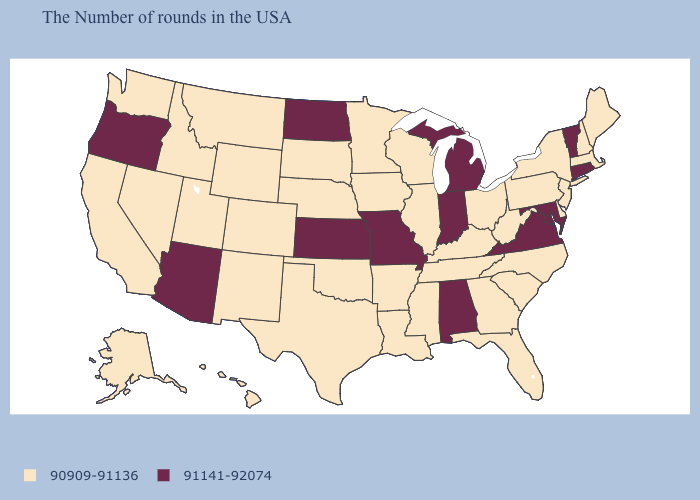Which states have the highest value in the USA?
Give a very brief answer. Rhode Island, Vermont, Connecticut, Maryland, Virginia, Michigan, Indiana, Alabama, Missouri, Kansas, North Dakota, Arizona, Oregon. Name the states that have a value in the range 90909-91136?
Concise answer only. Maine, Massachusetts, New Hampshire, New York, New Jersey, Delaware, Pennsylvania, North Carolina, South Carolina, West Virginia, Ohio, Florida, Georgia, Kentucky, Tennessee, Wisconsin, Illinois, Mississippi, Louisiana, Arkansas, Minnesota, Iowa, Nebraska, Oklahoma, Texas, South Dakota, Wyoming, Colorado, New Mexico, Utah, Montana, Idaho, Nevada, California, Washington, Alaska, Hawaii. Name the states that have a value in the range 90909-91136?
Write a very short answer. Maine, Massachusetts, New Hampshire, New York, New Jersey, Delaware, Pennsylvania, North Carolina, South Carolina, West Virginia, Ohio, Florida, Georgia, Kentucky, Tennessee, Wisconsin, Illinois, Mississippi, Louisiana, Arkansas, Minnesota, Iowa, Nebraska, Oklahoma, Texas, South Dakota, Wyoming, Colorado, New Mexico, Utah, Montana, Idaho, Nevada, California, Washington, Alaska, Hawaii. How many symbols are there in the legend?
Give a very brief answer. 2. Which states have the lowest value in the USA?
Keep it brief. Maine, Massachusetts, New Hampshire, New York, New Jersey, Delaware, Pennsylvania, North Carolina, South Carolina, West Virginia, Ohio, Florida, Georgia, Kentucky, Tennessee, Wisconsin, Illinois, Mississippi, Louisiana, Arkansas, Minnesota, Iowa, Nebraska, Oklahoma, Texas, South Dakota, Wyoming, Colorado, New Mexico, Utah, Montana, Idaho, Nevada, California, Washington, Alaska, Hawaii. What is the value of Texas?
Concise answer only. 90909-91136. What is the value of Alabama?
Answer briefly. 91141-92074. What is the highest value in the USA?
Write a very short answer. 91141-92074. What is the lowest value in the USA?
Answer briefly. 90909-91136. What is the value of North Dakota?
Concise answer only. 91141-92074. What is the highest value in states that border North Dakota?
Give a very brief answer. 90909-91136. Among the states that border South Dakota , which have the lowest value?
Keep it brief. Minnesota, Iowa, Nebraska, Wyoming, Montana. Name the states that have a value in the range 91141-92074?
Concise answer only. Rhode Island, Vermont, Connecticut, Maryland, Virginia, Michigan, Indiana, Alabama, Missouri, Kansas, North Dakota, Arizona, Oregon. Does Tennessee have the same value as Vermont?
Answer briefly. No. What is the value of Ohio?
Short answer required. 90909-91136. 